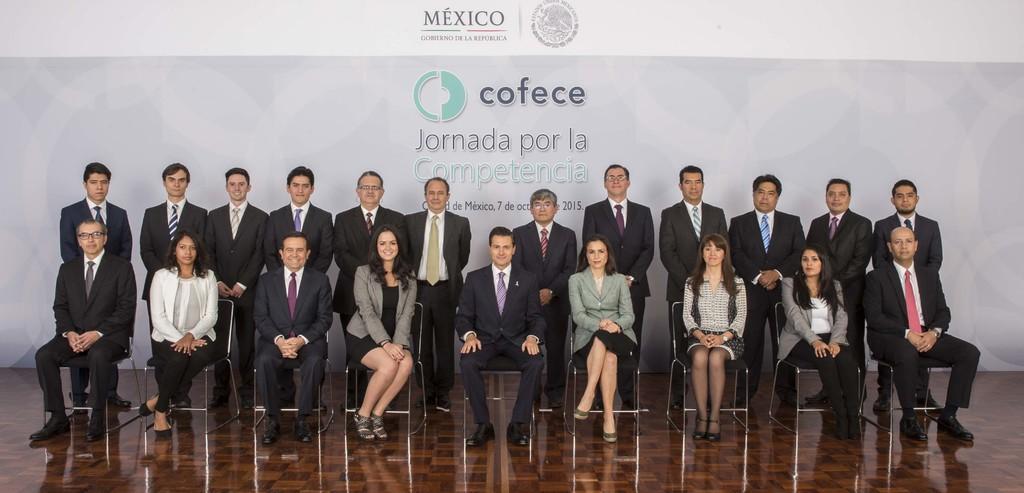Please provide a concise description of this image. In this image we can see a group of people sitting on chairs placed on the ground and a group of people wearing are standing. In the background, we can see a wall with some text on it. 